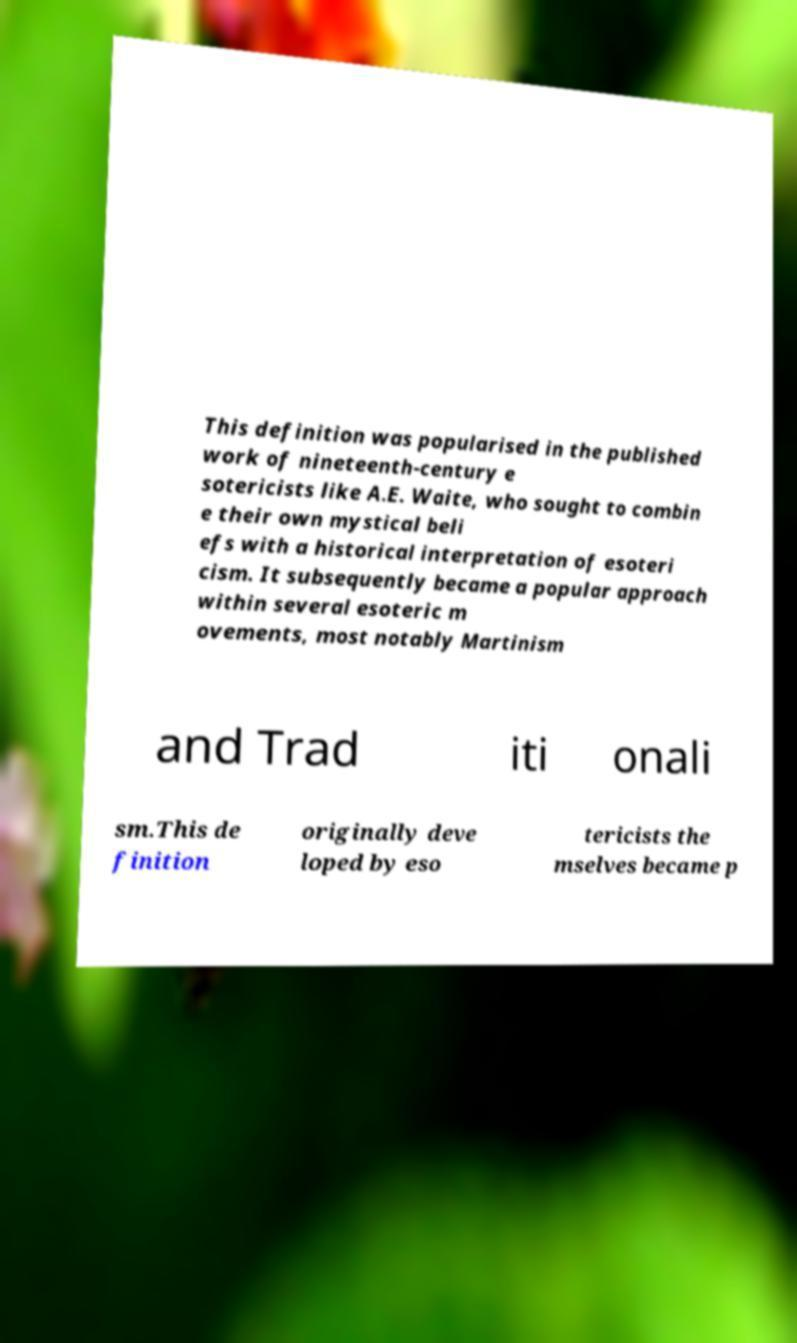Can you read and provide the text displayed in the image?This photo seems to have some interesting text. Can you extract and type it out for me? This definition was popularised in the published work of nineteenth-century e sotericists like A.E. Waite, who sought to combin e their own mystical beli efs with a historical interpretation of esoteri cism. It subsequently became a popular approach within several esoteric m ovements, most notably Martinism and Trad iti onali sm.This de finition originally deve loped by eso tericists the mselves became p 